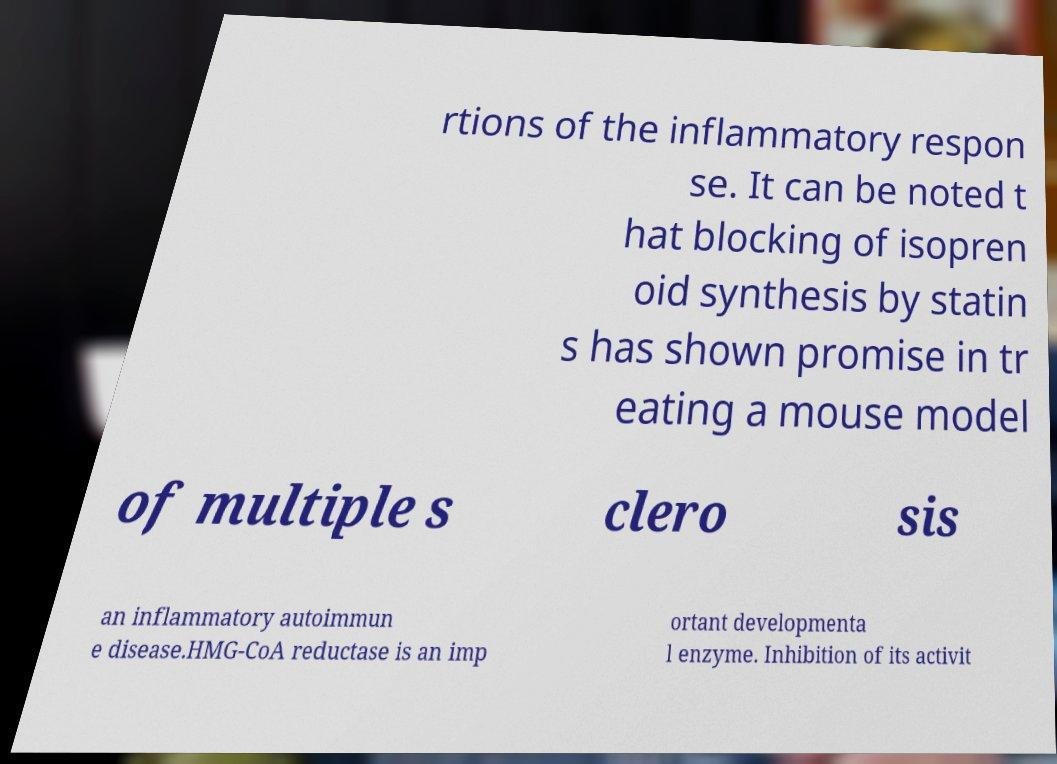What messages or text are displayed in this image? I need them in a readable, typed format. rtions of the inflammatory respon se. It can be noted t hat blocking of isopren oid synthesis by statin s has shown promise in tr eating a mouse model of multiple s clero sis an inflammatory autoimmun e disease.HMG-CoA reductase is an imp ortant developmenta l enzyme. Inhibition of its activit 